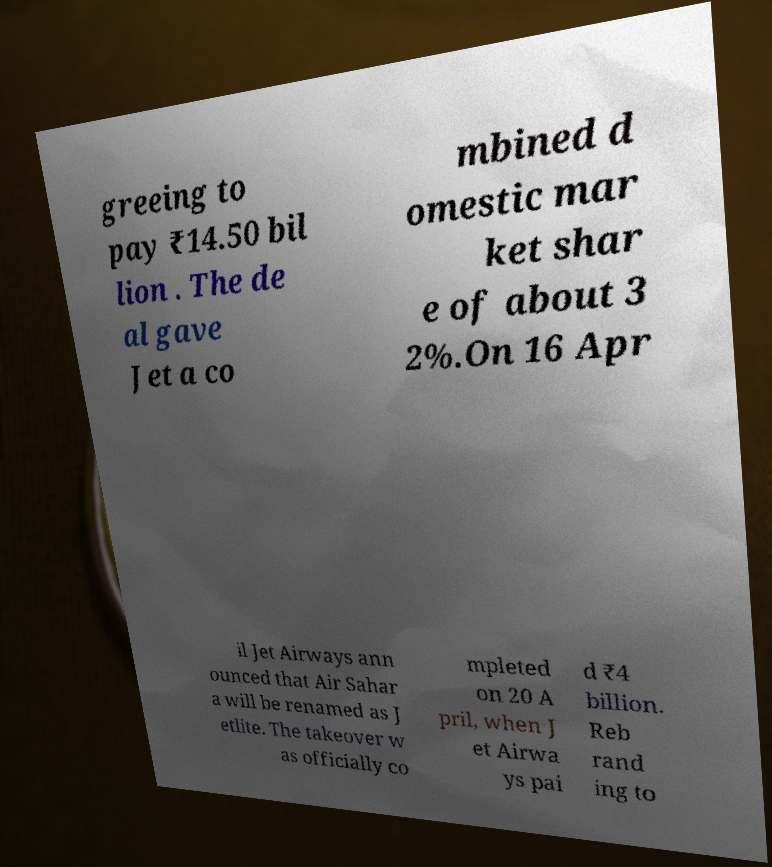Please read and relay the text visible in this image. What does it say? greeing to pay ₹14.50 bil lion . The de al gave Jet a co mbined d omestic mar ket shar e of about 3 2%.On 16 Apr il Jet Airways ann ounced that Air Sahar a will be renamed as J etlite. The takeover w as officially co mpleted on 20 A pril, when J et Airwa ys pai d ₹4 billion. Reb rand ing to 